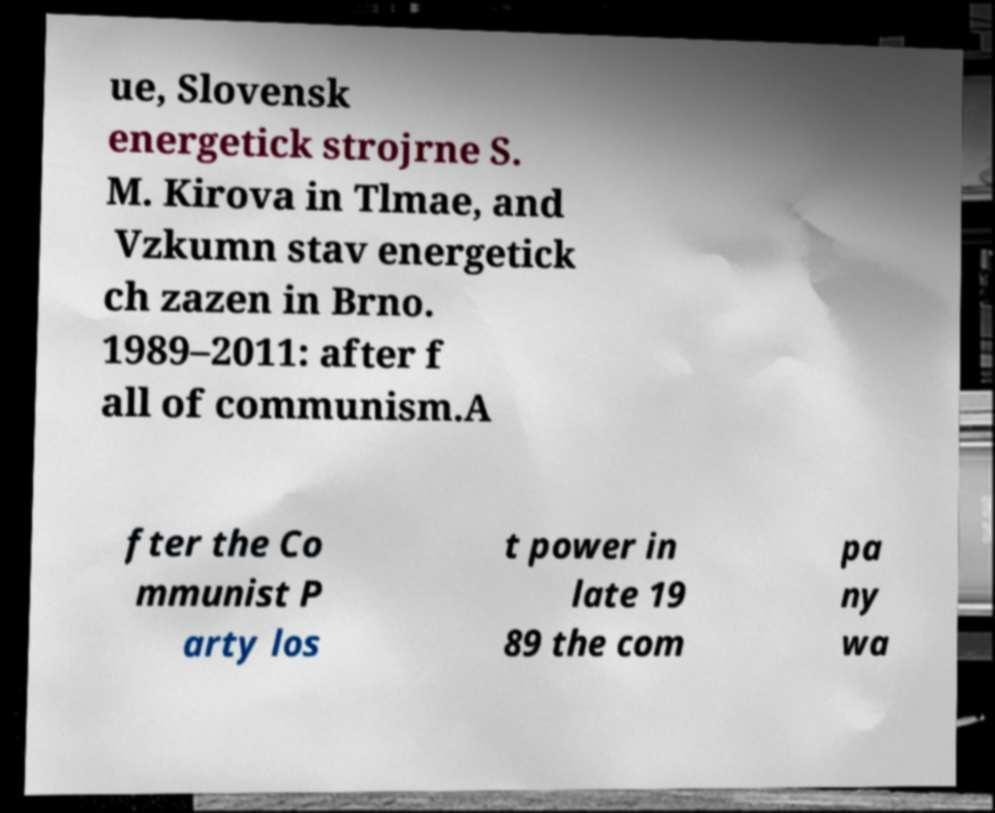Could you extract and type out the text from this image? ue, Slovensk energetick strojrne S. M. Kirova in Tlmae, and Vzkumn stav energetick ch zazen in Brno. 1989–2011: after f all of communism.A fter the Co mmunist P arty los t power in late 19 89 the com pa ny wa 